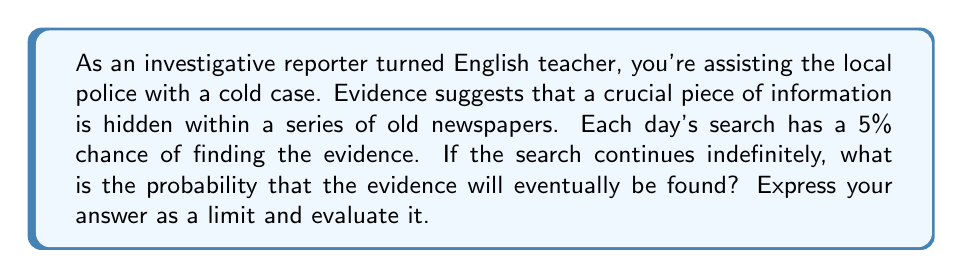Give your solution to this math problem. Let's approach this step-by-step:

1) First, let's define our probability:
   $p$ = probability of finding the evidence on any given day = 0.05 (5%)
   $q$ = probability of not finding the evidence on any given day = 1 - p = 0.95 (95%)

2) The probability of not finding the evidence in $n$ days is $q^n$.

3) Therefore, the probability of finding the evidence within $n$ days is $1 - q^n$.

4) As the search continues indefinitely, $n$ approaches infinity. We can express this as a limit:

   $$\lim_{n \to \infty} (1 - q^n)$$

5) Substituting our value for $q$:

   $$\lim_{n \to \infty} (1 - 0.95^n)$$

6) To evaluate this limit, we can use the fact that for $|x| < 1$, $\lim_{n \to \infty} x^n = 0$:

   Since $0.95 < 1$, $\lim_{n \to \infty} 0.95^n = 0$

7) Therefore:

   $$\lim_{n \to \infty} (1 - 0.95^n) = 1 - 0 = 1$$

This result makes intuitive sense: if we keep searching indefinitely with a non-zero probability of success each day, we will eventually find the evidence with certainty.
Answer: The probability that the evidence will eventually be found is 1, or 100%. This can be expressed as the limit:

$$\lim_{n \to \infty} (1 - 0.95^n) = 1$$ 